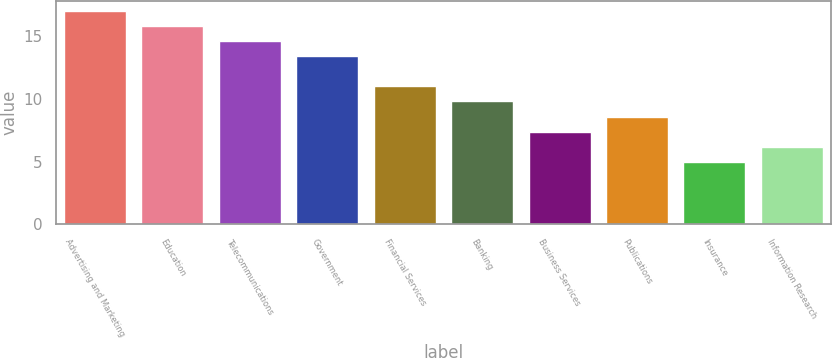Convert chart. <chart><loc_0><loc_0><loc_500><loc_500><bar_chart><fcel>Advertising and Marketing<fcel>Education<fcel>Telecommunications<fcel>Government<fcel>Financial Services<fcel>Banking<fcel>Business Services<fcel>Publications<fcel>Insurance<fcel>Information Research<nl><fcel>17<fcel>15.8<fcel>14.6<fcel>13.4<fcel>11<fcel>9.8<fcel>7.4<fcel>8.6<fcel>5<fcel>6.2<nl></chart> 